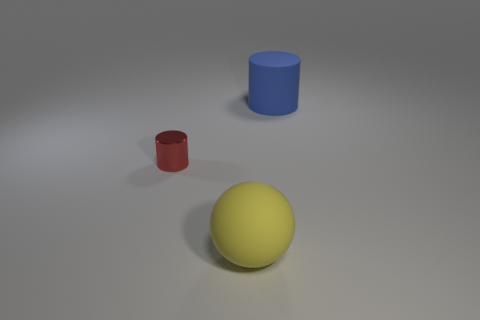Does the thing that is on the right side of the big yellow rubber ball have the same material as the cylinder in front of the blue rubber cylinder?
Give a very brief answer. No. What number of things are either small yellow matte balls or big rubber things that are on the left side of the large cylinder?
Your response must be concise. 1. Is there any other thing that has the same material as the small object?
Keep it short and to the point. No. What is the red cylinder made of?
Offer a very short reply. Metal. Do the large yellow thing and the blue object have the same material?
Your answer should be very brief. Yes. What number of rubber things are cylinders or small cylinders?
Offer a very short reply. 1. What shape is the matte thing behind the metallic object?
Ensure brevity in your answer.  Cylinder. What is the shape of the thing that is behind the large yellow thing and in front of the large blue cylinder?
Keep it short and to the point. Cylinder. Does the thing that is to the left of the yellow rubber sphere have the same shape as the big thing that is in front of the tiny red thing?
Your answer should be very brief. No. There is a cylinder on the left side of the yellow rubber ball; how big is it?
Your answer should be very brief. Small. 